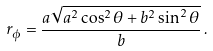Convert formula to latex. <formula><loc_0><loc_0><loc_500><loc_500>r _ { \phi } = \frac { a \sqrt { a ^ { 2 } \cos ^ { 2 } \theta + b ^ { 2 } \sin ^ { 2 } \theta } } { b } \, .</formula> 